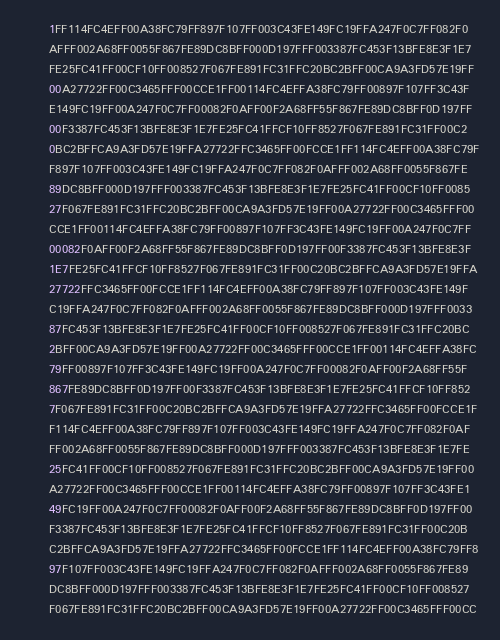Convert code to text. <code><loc_0><loc_0><loc_500><loc_500><_Pascal_>      1FF114FC4EFF00A38FC79FF897F107FF003C43FE149FC19FFA247F0C7FF082F0
      AFFF002A68FF0055F867FE89DC8BFF000D197FFF003387FC453F13BFE8E3F1E7
      FE25FC41FF00CF10FF008527F067FE891FC31FFC20BC2BFF00CA9A3FD57E19FF
      00A27722FF00C3465FFF00CCE1FF00114FC4EFFA38FC79FF00897F107FF3C43F
      E149FC19FF00A247F0C7FF00082F0AFF00F2A68FF55F867FE89DC8BFF0D197FF
      00F3387FC453F13BFE8E3F1E7FE25FC41FFCF10FF8527F067FE891FC31FF00C2
      0BC2BFFCA9A3FD57E19FFA27722FFC3465FF00FCCE1FF114FC4EFF00A38FC79F
      F897F107FF003C43FE149FC19FFA247F0C7FF082F0AFFF002A68FF0055F867FE
      89DC8BFF000D197FFF003387FC453F13BFE8E3F1E7FE25FC41FF00CF10FF0085
      27F067FE891FC31FFC20BC2BFF00CA9A3FD57E19FF00A27722FF00C3465FFF00
      CCE1FF00114FC4EFFA38FC79FF00897F107FF3C43FE149FC19FF00A247F0C7FF
      00082F0AFF00F2A68FF55F867FE89DC8BFF0D197FF00F3387FC453F13BFE8E3F
      1E7FE25FC41FFCF10FF8527F067FE891FC31FF00C20BC2BFFCA9A3FD57E19FFA
      27722FFC3465FF00FCCE1FF114FC4EFF00A38FC79FF897F107FF003C43FE149F
      C19FFA247F0C7FF082F0AFFF002A68FF0055F867FE89DC8BFF000D197FFF0033
      87FC453F13BFE8E3F1E7FE25FC41FF00CF10FF008527F067FE891FC31FFC20BC
      2BFF00CA9A3FD57E19FF00A27722FF00C3465FFF00CCE1FF00114FC4EFFA38FC
      79FF00897F107FF3C43FE149FC19FF00A247F0C7FF00082F0AFF00F2A68FF55F
      867FE89DC8BFF0D197FF00F3387FC453F13BFE8E3F1E7FE25FC41FFCF10FF852
      7F067FE891FC31FF00C20BC2BFFCA9A3FD57E19FFA27722FFC3465FF00FCCE1F
      F114FC4EFF00A38FC79FF897F107FF003C43FE149FC19FFA247F0C7FF082F0AF
      FF002A68FF0055F867FE89DC8BFF000D197FFF003387FC453F13BFE8E3F1E7FE
      25FC41FF00CF10FF008527F067FE891FC31FFC20BC2BFF00CA9A3FD57E19FF00
      A27722FF00C3465FFF00CCE1FF00114FC4EFFA38FC79FF00897F107FF3C43FE1
      49FC19FF00A247F0C7FF00082F0AFF00F2A68FF55F867FE89DC8BFF0D197FF00
      F3387FC453F13BFE8E3F1E7FE25FC41FFCF10FF8527F067FE891FC31FF00C20B
      C2BFFCA9A3FD57E19FFA27722FFC3465FF00FCCE1FF114FC4EFF00A38FC79FF8
      97F107FF003C43FE149FC19FFA247F0C7FF082F0AFFF002A68FF0055F867FE89
      DC8BFF000D197FFF003387FC453F13BFE8E3F1E7FE25FC41FF00CF10FF008527
      F067FE891FC31FFC20BC2BFF00CA9A3FD57E19FF00A27722FF00C3465FFF00CC</code> 